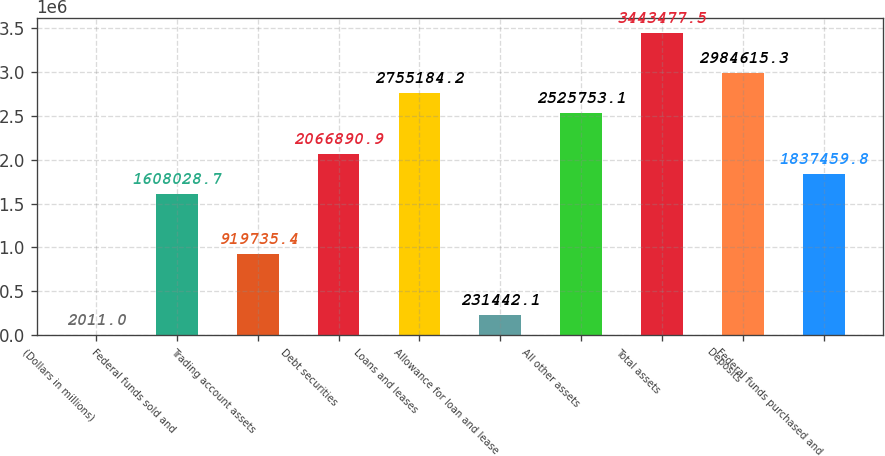Convert chart to OTSL. <chart><loc_0><loc_0><loc_500><loc_500><bar_chart><fcel>(Dollars in millions)<fcel>Federal funds sold and<fcel>Trading account assets<fcel>Debt securities<fcel>Loans and leases<fcel>Allowance for loan and lease<fcel>All other assets<fcel>Total assets<fcel>Deposits<fcel>Federal funds purchased and<nl><fcel>2011<fcel>1.60803e+06<fcel>919735<fcel>2.06689e+06<fcel>2.75518e+06<fcel>231442<fcel>2.52575e+06<fcel>3.44348e+06<fcel>2.98462e+06<fcel>1.83746e+06<nl></chart> 